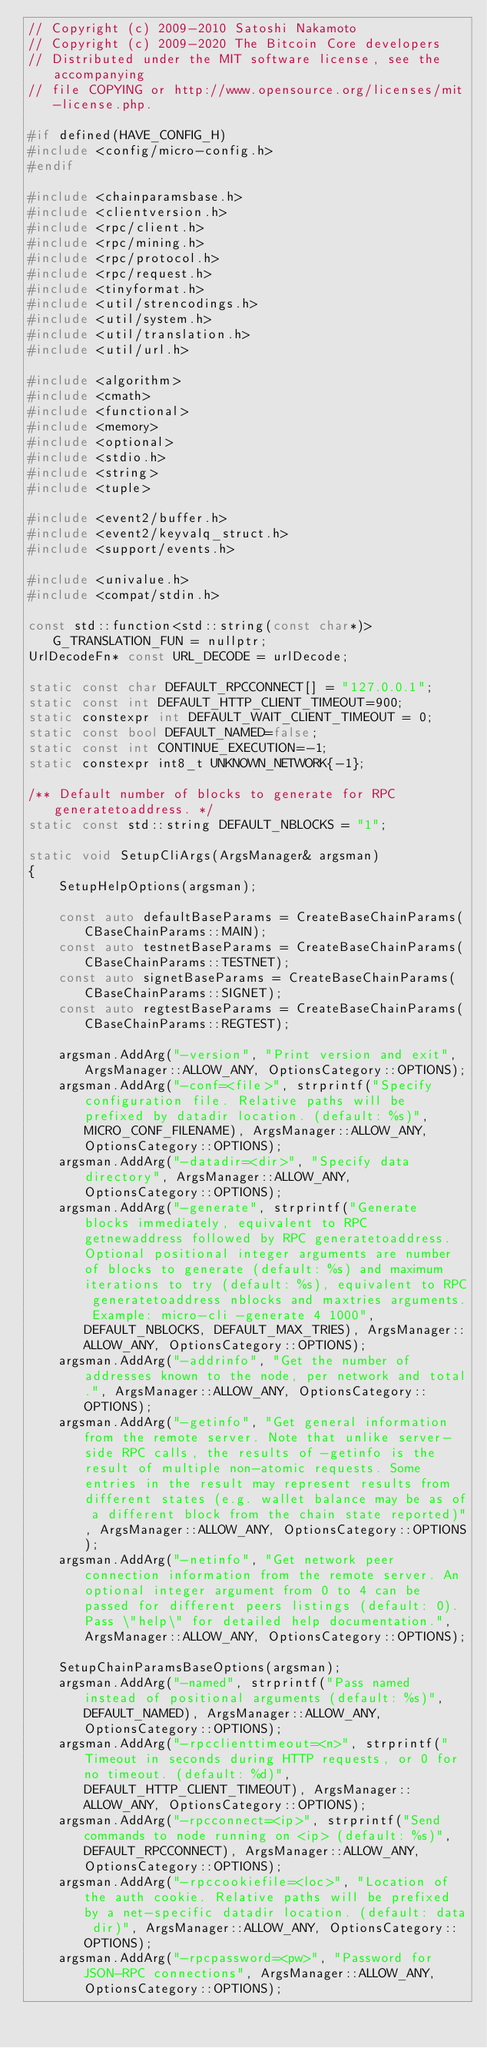Convert code to text. <code><loc_0><loc_0><loc_500><loc_500><_C++_>// Copyright (c) 2009-2010 Satoshi Nakamoto
// Copyright (c) 2009-2020 The Bitcoin Core developers
// Distributed under the MIT software license, see the accompanying
// file COPYING or http://www.opensource.org/licenses/mit-license.php.

#if defined(HAVE_CONFIG_H)
#include <config/micro-config.h>
#endif

#include <chainparamsbase.h>
#include <clientversion.h>
#include <rpc/client.h>
#include <rpc/mining.h>
#include <rpc/protocol.h>
#include <rpc/request.h>
#include <tinyformat.h>
#include <util/strencodings.h>
#include <util/system.h>
#include <util/translation.h>
#include <util/url.h>

#include <algorithm>
#include <cmath>
#include <functional>
#include <memory>
#include <optional>
#include <stdio.h>
#include <string>
#include <tuple>

#include <event2/buffer.h>
#include <event2/keyvalq_struct.h>
#include <support/events.h>

#include <univalue.h>
#include <compat/stdin.h>

const std::function<std::string(const char*)> G_TRANSLATION_FUN = nullptr;
UrlDecodeFn* const URL_DECODE = urlDecode;

static const char DEFAULT_RPCCONNECT[] = "127.0.0.1";
static const int DEFAULT_HTTP_CLIENT_TIMEOUT=900;
static constexpr int DEFAULT_WAIT_CLIENT_TIMEOUT = 0;
static const bool DEFAULT_NAMED=false;
static const int CONTINUE_EXECUTION=-1;
static constexpr int8_t UNKNOWN_NETWORK{-1};

/** Default number of blocks to generate for RPC generatetoaddress. */
static const std::string DEFAULT_NBLOCKS = "1";

static void SetupCliArgs(ArgsManager& argsman)
{
    SetupHelpOptions(argsman);

    const auto defaultBaseParams = CreateBaseChainParams(CBaseChainParams::MAIN);
    const auto testnetBaseParams = CreateBaseChainParams(CBaseChainParams::TESTNET);
    const auto signetBaseParams = CreateBaseChainParams(CBaseChainParams::SIGNET);
    const auto regtestBaseParams = CreateBaseChainParams(CBaseChainParams::REGTEST);

    argsman.AddArg("-version", "Print version and exit", ArgsManager::ALLOW_ANY, OptionsCategory::OPTIONS);
    argsman.AddArg("-conf=<file>", strprintf("Specify configuration file. Relative paths will be prefixed by datadir location. (default: %s)", MICRO_CONF_FILENAME), ArgsManager::ALLOW_ANY, OptionsCategory::OPTIONS);
    argsman.AddArg("-datadir=<dir>", "Specify data directory", ArgsManager::ALLOW_ANY, OptionsCategory::OPTIONS);
    argsman.AddArg("-generate", strprintf("Generate blocks immediately, equivalent to RPC getnewaddress followed by RPC generatetoaddress. Optional positional integer arguments are number of blocks to generate (default: %s) and maximum iterations to try (default: %s), equivalent to RPC generatetoaddress nblocks and maxtries arguments. Example: micro-cli -generate 4 1000", DEFAULT_NBLOCKS, DEFAULT_MAX_TRIES), ArgsManager::ALLOW_ANY, OptionsCategory::OPTIONS);
    argsman.AddArg("-addrinfo", "Get the number of addresses known to the node, per network and total.", ArgsManager::ALLOW_ANY, OptionsCategory::OPTIONS);
    argsman.AddArg("-getinfo", "Get general information from the remote server. Note that unlike server-side RPC calls, the results of -getinfo is the result of multiple non-atomic requests. Some entries in the result may represent results from different states (e.g. wallet balance may be as of a different block from the chain state reported)", ArgsManager::ALLOW_ANY, OptionsCategory::OPTIONS);
    argsman.AddArg("-netinfo", "Get network peer connection information from the remote server. An optional integer argument from 0 to 4 can be passed for different peers listings (default: 0). Pass \"help\" for detailed help documentation.", ArgsManager::ALLOW_ANY, OptionsCategory::OPTIONS);

    SetupChainParamsBaseOptions(argsman);
    argsman.AddArg("-named", strprintf("Pass named instead of positional arguments (default: %s)", DEFAULT_NAMED), ArgsManager::ALLOW_ANY, OptionsCategory::OPTIONS);
    argsman.AddArg("-rpcclienttimeout=<n>", strprintf("Timeout in seconds during HTTP requests, or 0 for no timeout. (default: %d)", DEFAULT_HTTP_CLIENT_TIMEOUT), ArgsManager::ALLOW_ANY, OptionsCategory::OPTIONS);
    argsman.AddArg("-rpcconnect=<ip>", strprintf("Send commands to node running on <ip> (default: %s)", DEFAULT_RPCCONNECT), ArgsManager::ALLOW_ANY, OptionsCategory::OPTIONS);
    argsman.AddArg("-rpccookiefile=<loc>", "Location of the auth cookie. Relative paths will be prefixed by a net-specific datadir location. (default: data dir)", ArgsManager::ALLOW_ANY, OptionsCategory::OPTIONS);
    argsman.AddArg("-rpcpassword=<pw>", "Password for JSON-RPC connections", ArgsManager::ALLOW_ANY, OptionsCategory::OPTIONS);</code> 